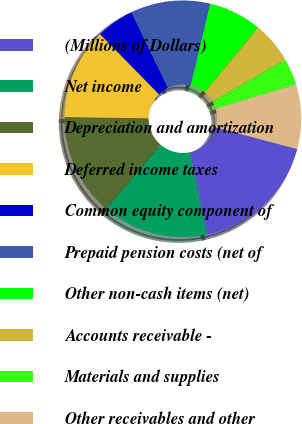Convert chart to OTSL. <chart><loc_0><loc_0><loc_500><loc_500><pie_chart><fcel>(Millions of Dollars)<fcel>Net income<fcel>Depreciation and amortization<fcel>Deferred income taxes<fcel>Common equity component of<fcel>Prepaid pension costs (net of<fcel>Other non-cash items (net)<fcel>Accounts receivable -<fcel>Materials and supplies<fcel>Other receivables and other<nl><fcel>17.61%<fcel>14.51%<fcel>13.99%<fcel>12.43%<fcel>5.18%<fcel>10.88%<fcel>7.25%<fcel>5.7%<fcel>3.63%<fcel>8.81%<nl></chart> 